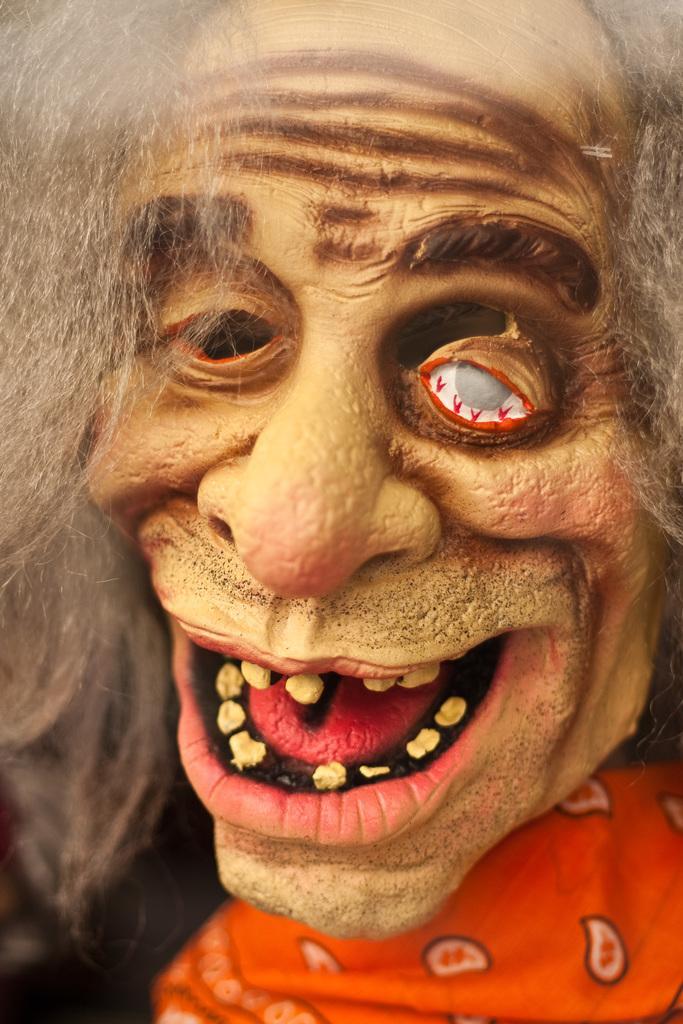Can you describe this image briefly? In this picture I can see the statue of an old man who looks like a zombie. 